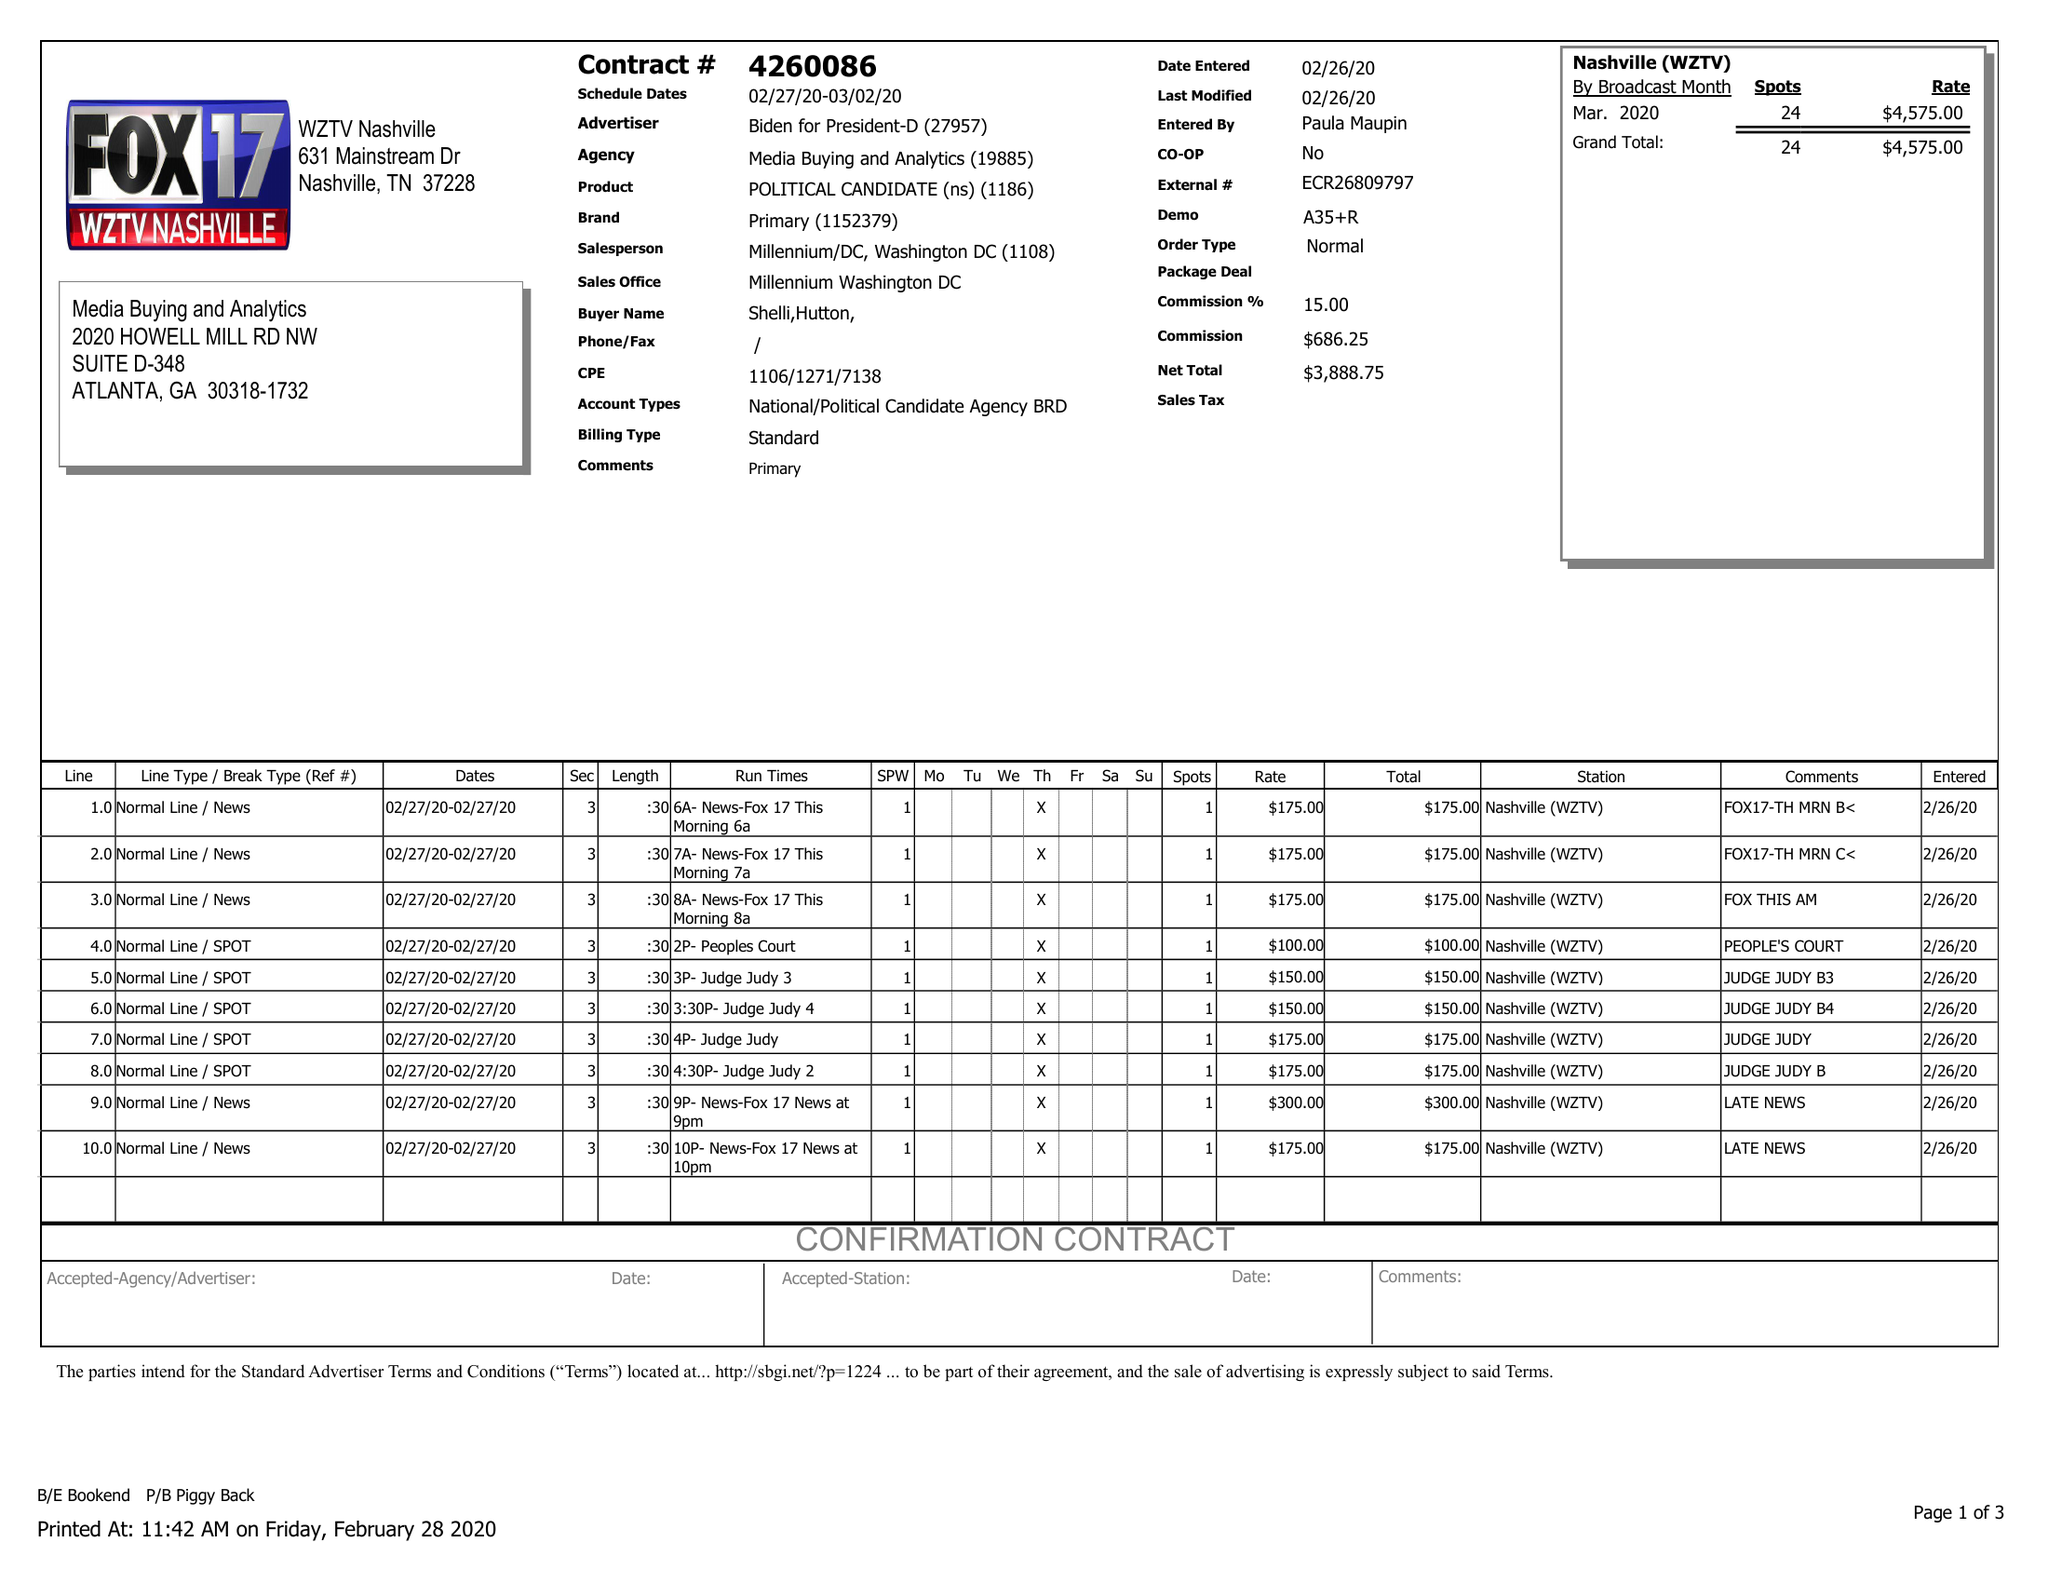What is the value for the contract_num?
Answer the question using a single word or phrase. 4260086 